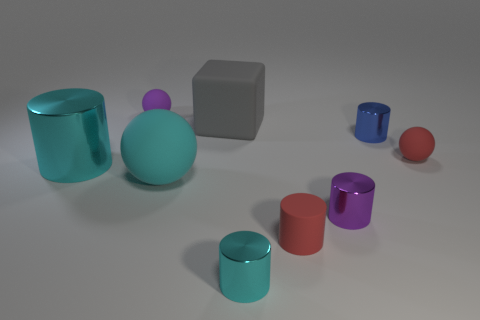Subtract all purple cylinders. How many cylinders are left? 4 Subtract all red cylinders. How many cylinders are left? 4 Subtract all brown cylinders. Subtract all blue blocks. How many cylinders are left? 5 Add 1 red rubber cylinders. How many objects exist? 10 Subtract all blocks. How many objects are left? 8 Subtract 1 red cylinders. How many objects are left? 8 Subtract all brown shiny blocks. Subtract all small purple metal things. How many objects are left? 8 Add 8 tiny red rubber cylinders. How many tiny red rubber cylinders are left? 9 Add 3 blue metallic things. How many blue metallic things exist? 4 